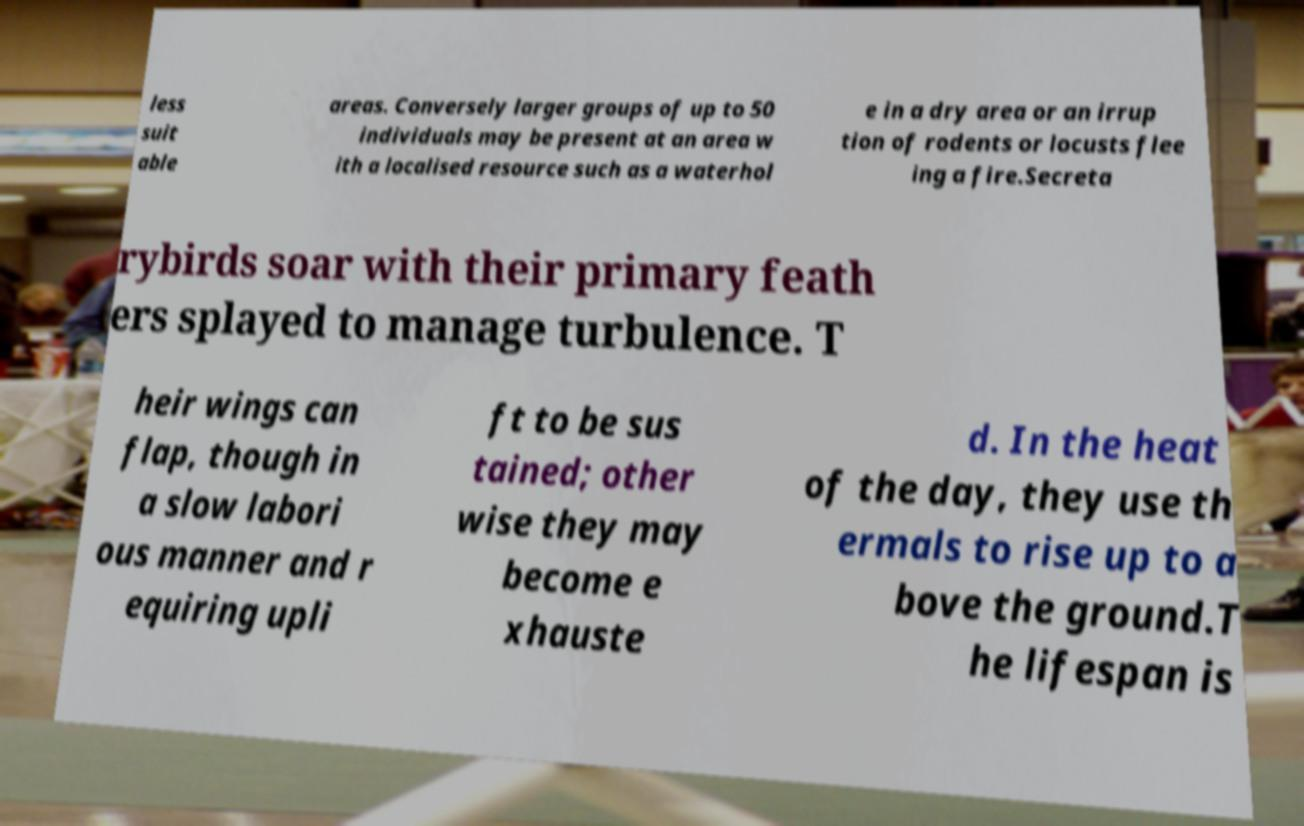Can you accurately transcribe the text from the provided image for me? less suit able areas. Conversely larger groups of up to 50 individuals may be present at an area w ith a localised resource such as a waterhol e in a dry area or an irrup tion of rodents or locusts flee ing a fire.Secreta rybirds soar with their primary feath ers splayed to manage turbulence. T heir wings can flap, though in a slow labori ous manner and r equiring upli ft to be sus tained; other wise they may become e xhauste d. In the heat of the day, they use th ermals to rise up to a bove the ground.T he lifespan is 